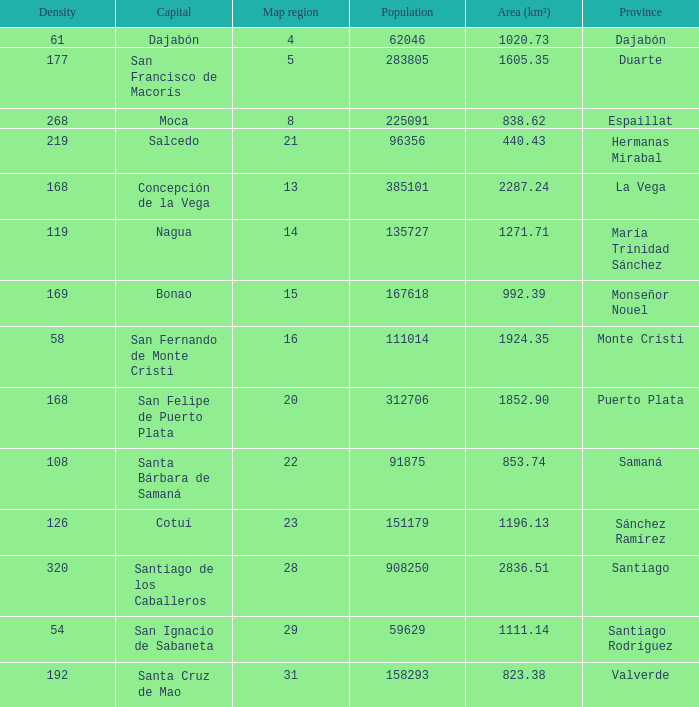When area (km²) is 1605.35, how many provinces are there? 1.0. 